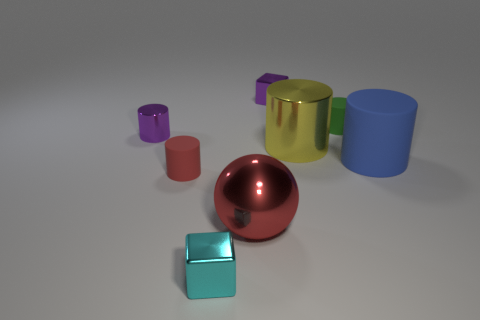What is the material of the small purple thing to the right of the small purple thing to the left of the red cylinder?
Provide a short and direct response. Metal. How big is the matte cylinder left of the ball?
Make the answer very short. Small. Is the color of the large ball the same as the tiny cube behind the red metallic sphere?
Offer a very short reply. No. Are there any tiny things of the same color as the large rubber cylinder?
Give a very brief answer. No. Is the tiny purple cylinder made of the same material as the large cylinder that is behind the blue thing?
Ensure brevity in your answer.  Yes. How many large things are either rubber things or red things?
Provide a succinct answer. 2. What is the material of the cylinder that is the same color as the large metal ball?
Your answer should be very brief. Rubber. Are there fewer tiny cyan metallic cubes than blue metallic objects?
Give a very brief answer. No. There is a metal cylinder on the left side of the red shiny sphere; is its size the same as the purple block behind the tiny cyan cube?
Ensure brevity in your answer.  Yes. What number of green objects are either small rubber cylinders or tiny metal cubes?
Provide a succinct answer. 1. 